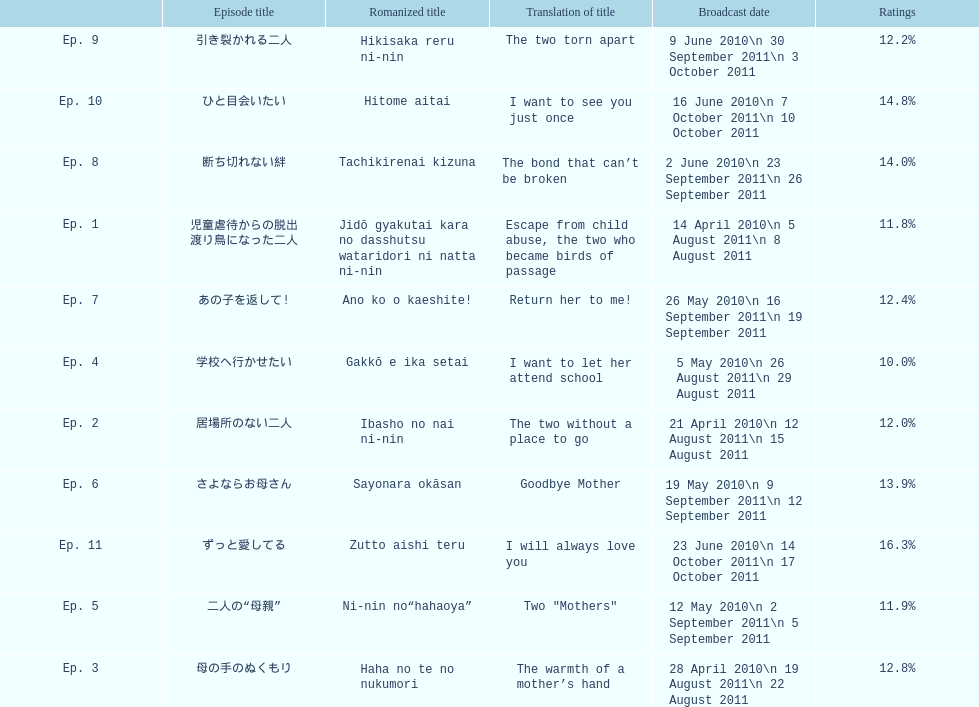Write the full table. {'header': ['', 'Episode title', 'Romanized title', 'Translation of title', 'Broadcast date', 'Ratings'], 'rows': [['Ep. 9', '引き裂かれる二人', 'Hikisaka reru ni-nin', 'The two torn apart', '9 June 2010\\n 30 September 2011\\n 3 October 2011', '12.2%'], ['Ep. 10', 'ひと目会いたい', 'Hitome aitai', 'I want to see you just once', '16 June 2010\\n 7 October 2011\\n 10 October 2011', '14.8%'], ['Ep. 8', '断ち切れない絆', 'Tachikirenai kizuna', 'The bond that can’t be broken', '2 June 2010\\n 23 September 2011\\n 26 September 2011', '14.0%'], ['Ep. 1', '児童虐待からの脱出 渡り鳥になった二人', 'Jidō gyakutai kara no dasshutsu wataridori ni natta ni-nin', 'Escape from child abuse, the two who became birds of passage', '14 April 2010\\n 5 August 2011\\n 8 August 2011', '11.8%'], ['Ep. 7', 'あの子を返して!', 'Ano ko o kaeshite!', 'Return her to me!', '26 May 2010\\n 16 September 2011\\n 19 September 2011', '12.4%'], ['Ep. 4', '学校へ行かせたい', 'Gakkō e ika setai', 'I want to let her attend school', '5 May 2010\\n 26 August 2011\\n 29 August 2011', '10.0%'], ['Ep. 2', '居場所のない二人', 'Ibasho no nai ni-nin', 'The two without a place to go', '21 April 2010\\n 12 August 2011\\n 15 August 2011', '12.0%'], ['Ep. 6', 'さよならお母さん', 'Sayonara okāsan', 'Goodbye Mother', '19 May 2010\\n 9 September 2011\\n 12 September 2011', '13.9%'], ['Ep. 11', 'ずっと愛してる', 'Zutto aishi teru', 'I will always love you', '23 June 2010\\n 14 October 2011\\n 17 October 2011', '16.3%'], ['Ep. 5', '二人の“母親”', 'Ni-nin no“hahaoya”', 'Two "Mothers"', '12 May 2010\\n 2 September 2011\\n 5 September 2011', '11.9%'], ['Ep. 3', '母の手のぬくもり', 'Haha no te no nukumori', 'The warmth of a mother’s hand', '28 April 2010\\n 19 August 2011\\n 22 August 2011', '12.8%']]} What is the number of episodes with a continuous rating of over 11%? 7. 